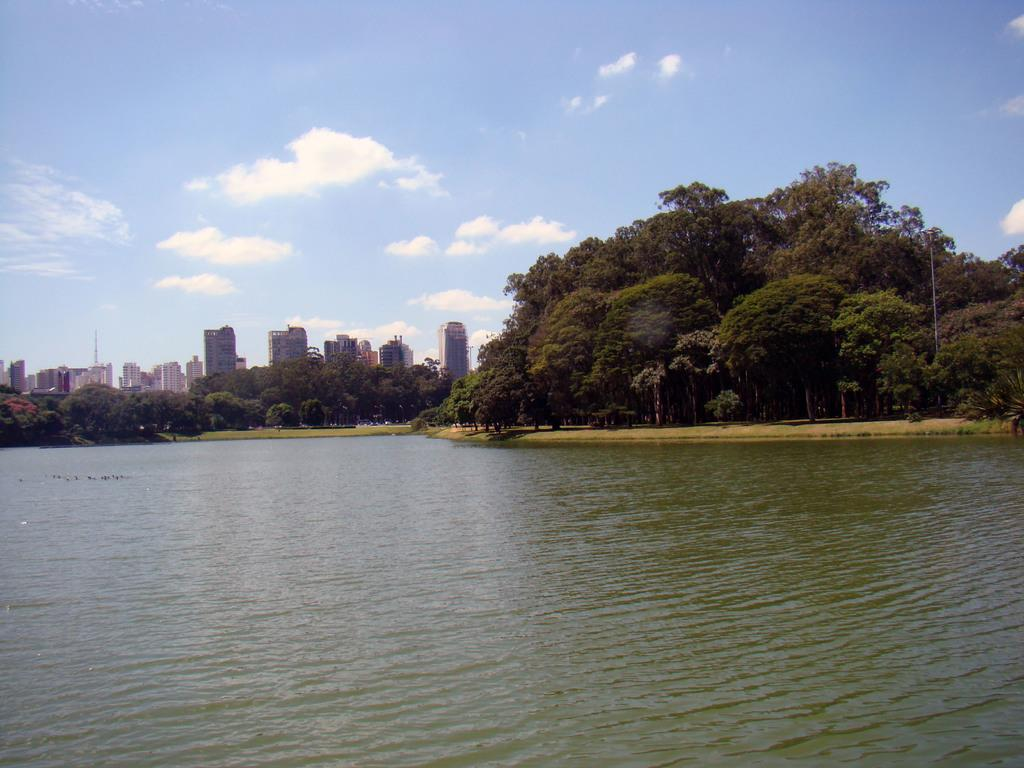What is located in front of the image? There is water in front of the image. What can be seen in the center of the image? There are trees and buildings in the center of the image. What is visible in the background of the image? The sky is visible in the background of the image. What is the condition of the sky in the image? The sky is clear in the image. Can you see a pocket in the trees in the image? There is no pocket present in the trees in the image. What type of ray is swimming in the water in the image? There is no ray present in the water in the image. 